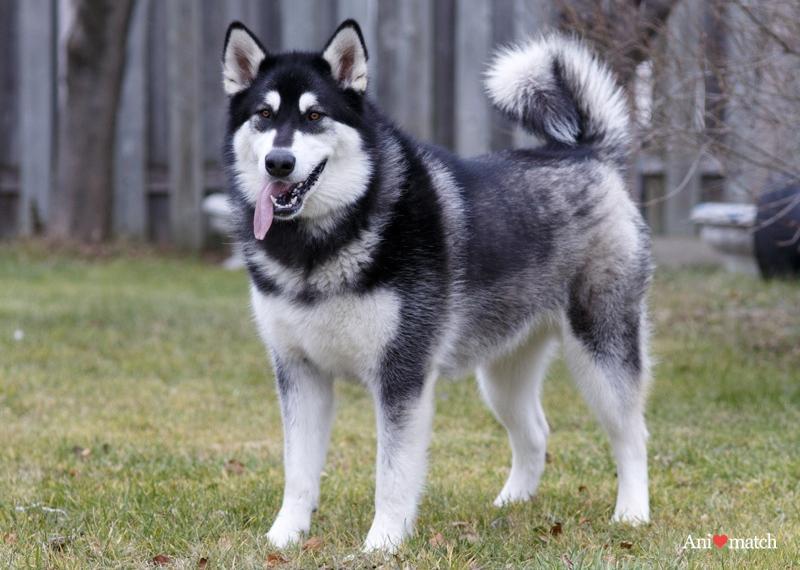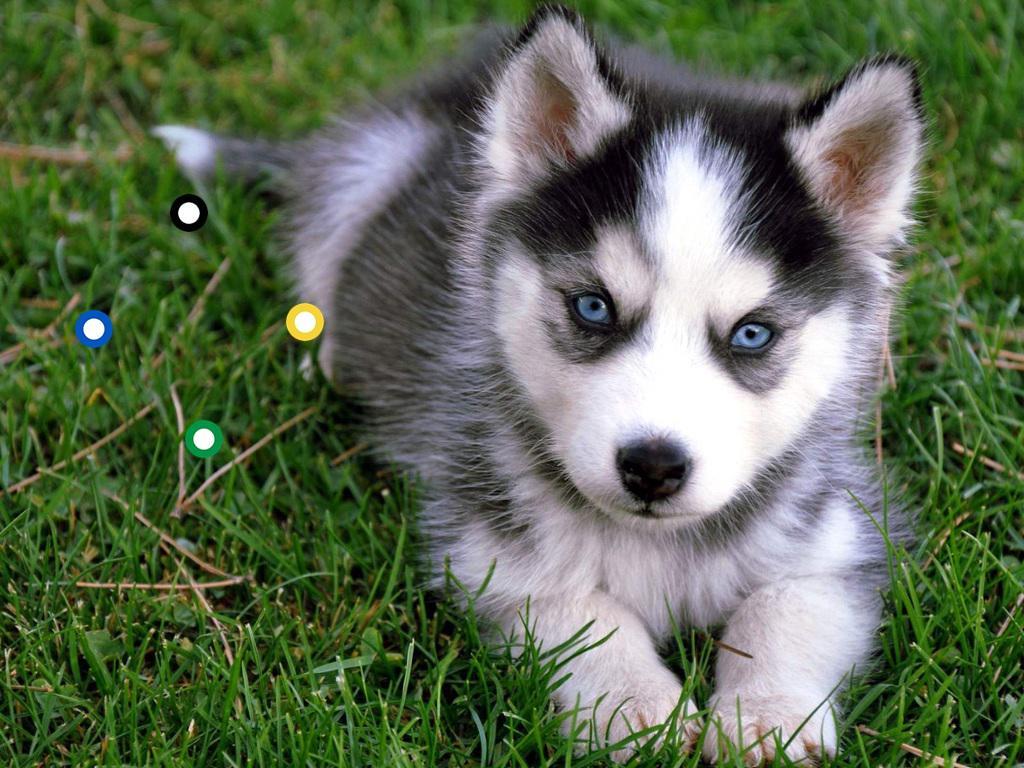The first image is the image on the left, the second image is the image on the right. Assess this claim about the two images: "There is a single puppy husky with blue eyes and white, black fur laying in the grass.". Correct or not? Answer yes or no. Yes. The first image is the image on the left, the second image is the image on the right. Analyze the images presented: Is the assertion "A dog is standing." valid? Answer yes or no. Yes. 